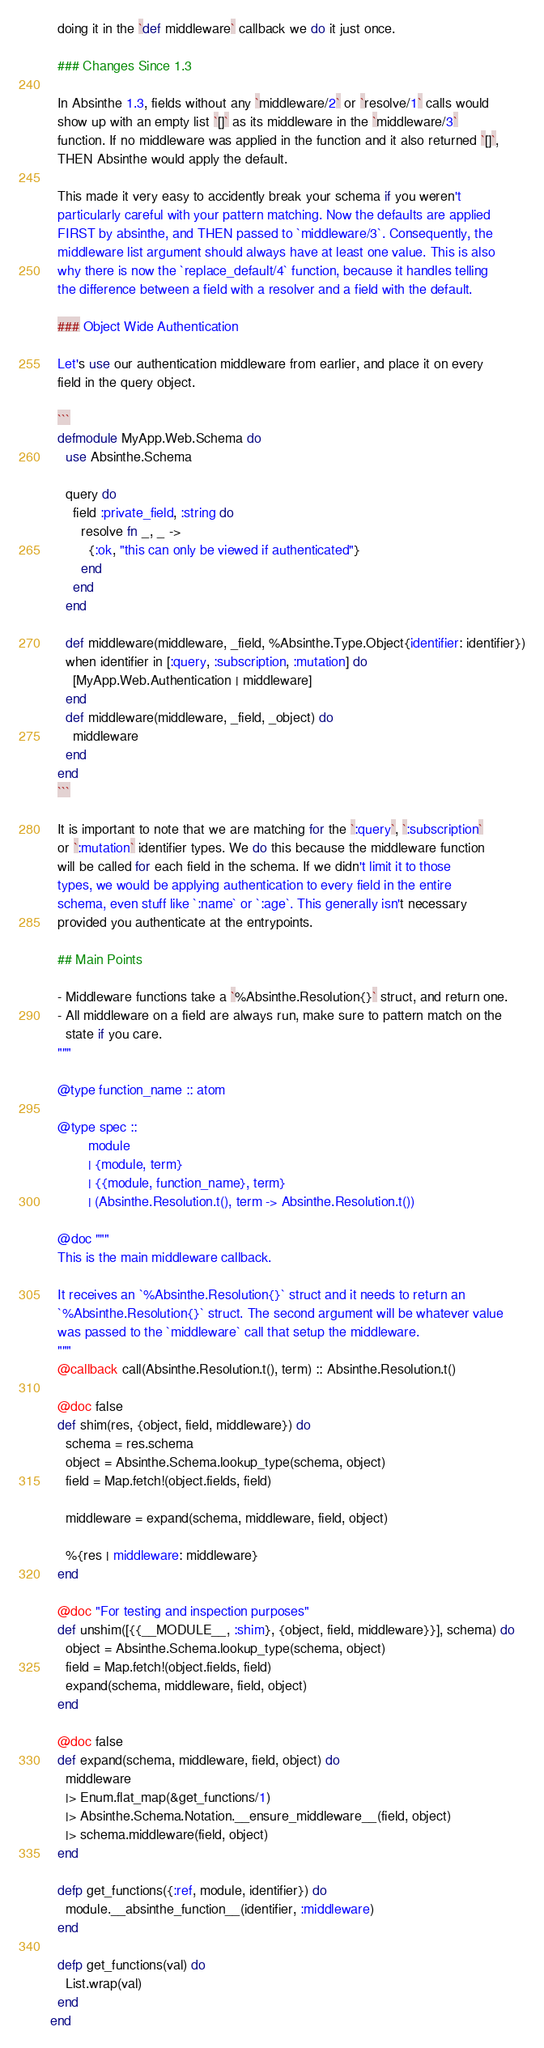<code> <loc_0><loc_0><loc_500><loc_500><_Elixir_>  doing it in the `def middleware` callback we do it just once.

  ### Changes Since 1.3

  In Absinthe 1.3, fields without any `middleware/2` or `resolve/1` calls would
  show up with an empty list `[]` as its middleware in the `middleware/3`
  function. If no middleware was applied in the function and it also returned `[]`,
  THEN Absinthe would apply the default.

  This made it very easy to accidently break your schema if you weren't
  particularly careful with your pattern matching. Now the defaults are applied
  FIRST by absinthe, and THEN passed to `middleware/3`. Consequently, the
  middleware list argument should always have at least one value. This is also
  why there is now the `replace_default/4` function, because it handles telling
  the difference between a field with a resolver and a field with the default.

  ### Object Wide Authentication

  Let's use our authentication middleware from earlier, and place it on every
  field in the query object.

  ```
  defmodule MyApp.Web.Schema do
    use Absinthe.Schema

    query do
      field :private_field, :string do
        resolve fn _, _ ->
          {:ok, "this can only be viewed if authenticated"}
        end
      end
    end

    def middleware(middleware, _field, %Absinthe.Type.Object{identifier: identifier})
    when identifier in [:query, :subscription, :mutation] do
      [MyApp.Web.Authentication | middleware]
    end
    def middleware(middleware, _field, _object) do
      middleware
    end
  end
  ```

  It is important to note that we are matching for the `:query`, `:subscription`
  or `:mutation` identifier types. We do this because the middleware function
  will be called for each field in the schema. If we didn't limit it to those
  types, we would be applying authentication to every field in the entire
  schema, even stuff like `:name` or `:age`. This generally isn't necessary
  provided you authenticate at the entrypoints.

  ## Main Points

  - Middleware functions take a `%Absinthe.Resolution{}` struct, and return one.
  - All middleware on a field are always run, make sure to pattern match on the
    state if you care.
  """

  @type function_name :: atom

  @type spec ::
          module
          | {module, term}
          | {{module, function_name}, term}
          | (Absinthe.Resolution.t(), term -> Absinthe.Resolution.t())

  @doc """
  This is the main middleware callback.

  It receives an `%Absinthe.Resolution{}` struct and it needs to return an
  `%Absinthe.Resolution{}` struct. The second argument will be whatever value
  was passed to the `middleware` call that setup the middleware.
  """
  @callback call(Absinthe.Resolution.t(), term) :: Absinthe.Resolution.t()

  @doc false
  def shim(res, {object, field, middleware}) do
    schema = res.schema
    object = Absinthe.Schema.lookup_type(schema, object)
    field = Map.fetch!(object.fields, field)

    middleware = expand(schema, middleware, field, object)

    %{res | middleware: middleware}
  end

  @doc "For testing and inspection purposes"
  def unshim([{{__MODULE__, :shim}, {object, field, middleware}}], schema) do
    object = Absinthe.Schema.lookup_type(schema, object)
    field = Map.fetch!(object.fields, field)
    expand(schema, middleware, field, object)
  end

  @doc false
  def expand(schema, middleware, field, object) do
    middleware
    |> Enum.flat_map(&get_functions/1)
    |> Absinthe.Schema.Notation.__ensure_middleware__(field, object)
    |> schema.middleware(field, object)
  end

  defp get_functions({:ref, module, identifier}) do
    module.__absinthe_function__(identifier, :middleware)
  end

  defp get_functions(val) do
    List.wrap(val)
  end
end
</code> 